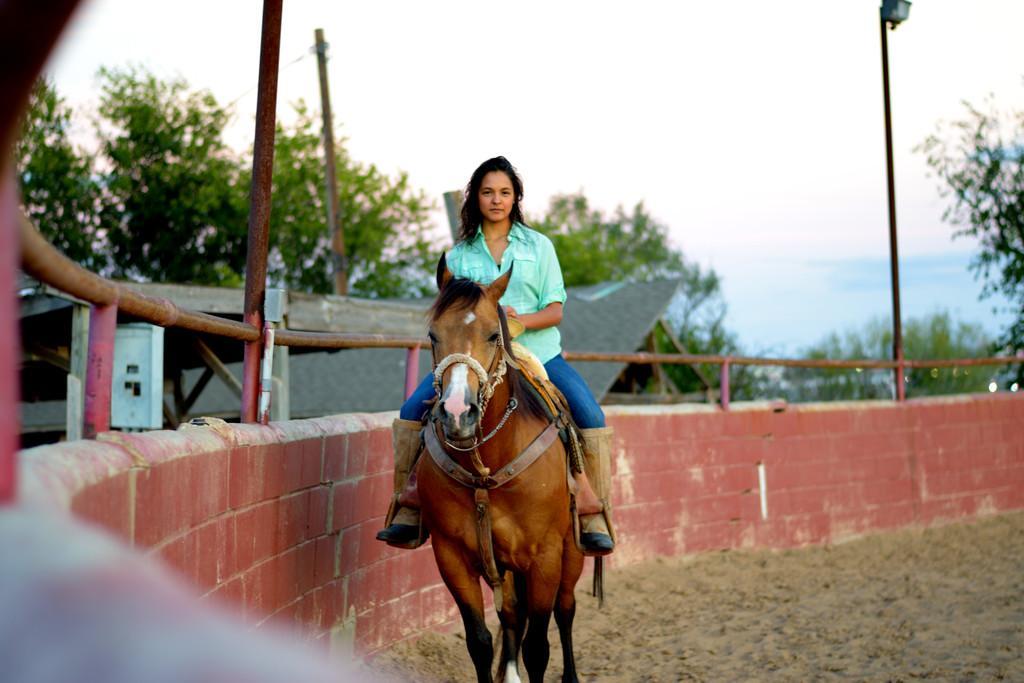Could you give a brief overview of what you see in this image? In this image we can see a woman riding a horse on the ground, beside the woman there is a wall with iron railing and a pole with light, a box and in the background there is a shed, few trees, a pole with wires and the sky. 